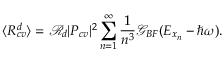<formula> <loc_0><loc_0><loc_500><loc_500>\langle R _ { c v } ^ { d } \rangle = \mathcal { R } _ { d } | P _ { c v } | ^ { 2 } \sum _ { n = 1 } ^ { \infty } \frac { 1 } { n ^ { 3 } } \mathcal { G } _ { B F } ( E _ { x _ { n } } - \hbar { \omega } ) .</formula> 